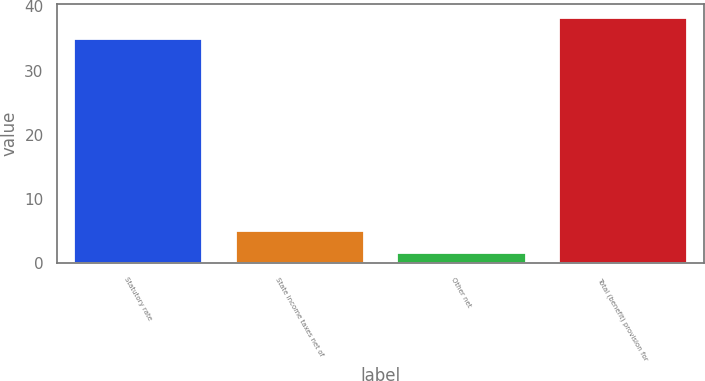Convert chart to OTSL. <chart><loc_0><loc_0><loc_500><loc_500><bar_chart><fcel>Statutory rate<fcel>State income taxes net of<fcel>Other net<fcel>Total (benefit) provision for<nl><fcel>35<fcel>5.11<fcel>1.7<fcel>38.41<nl></chart> 